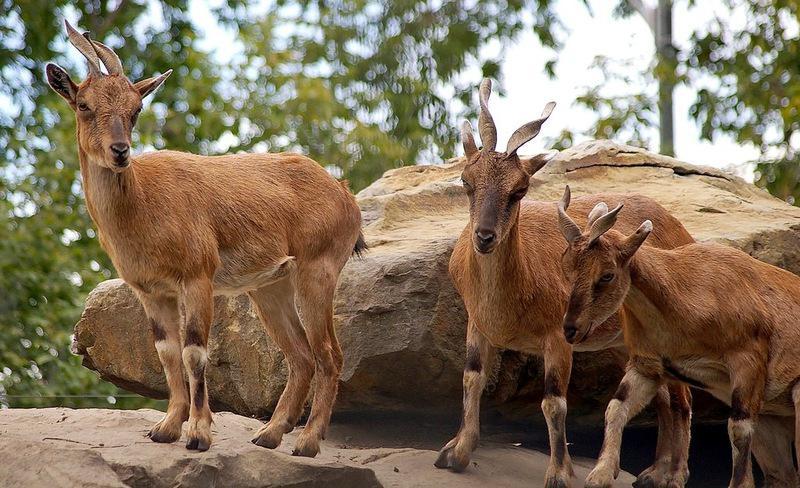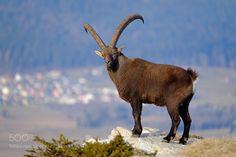The first image is the image on the left, the second image is the image on the right. Given the left and right images, does the statement "The left image shows two goats that are touching each other." hold true? Answer yes or no. No. The first image is the image on the left, the second image is the image on the right. For the images shown, is this caption "The left and right image contains a total of three goats." true? Answer yes or no. No. 